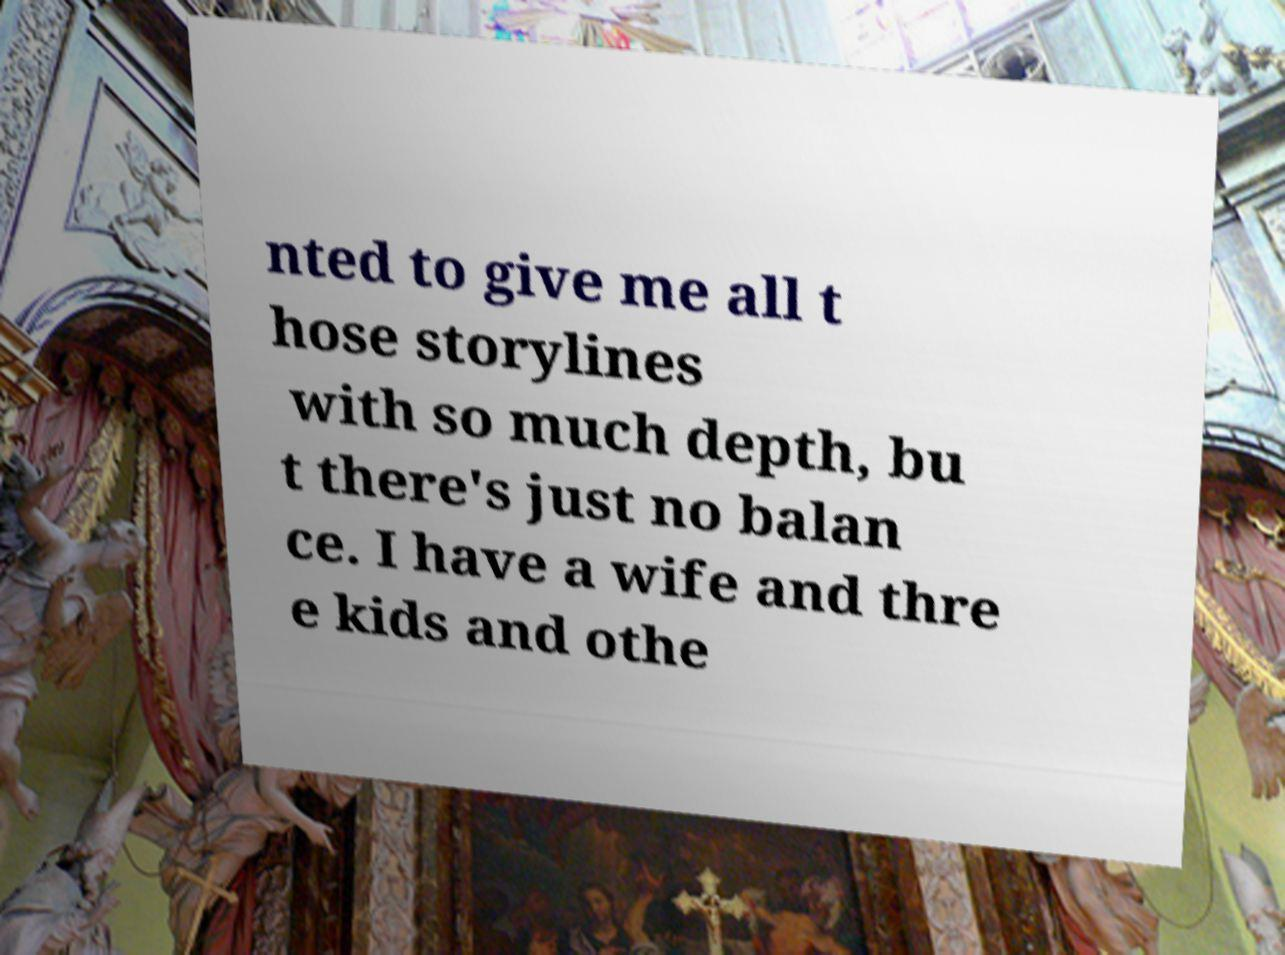Please read and relay the text visible in this image. What does it say? nted to give me all t hose storylines with so much depth, bu t there's just no balan ce. I have a wife and thre e kids and othe 